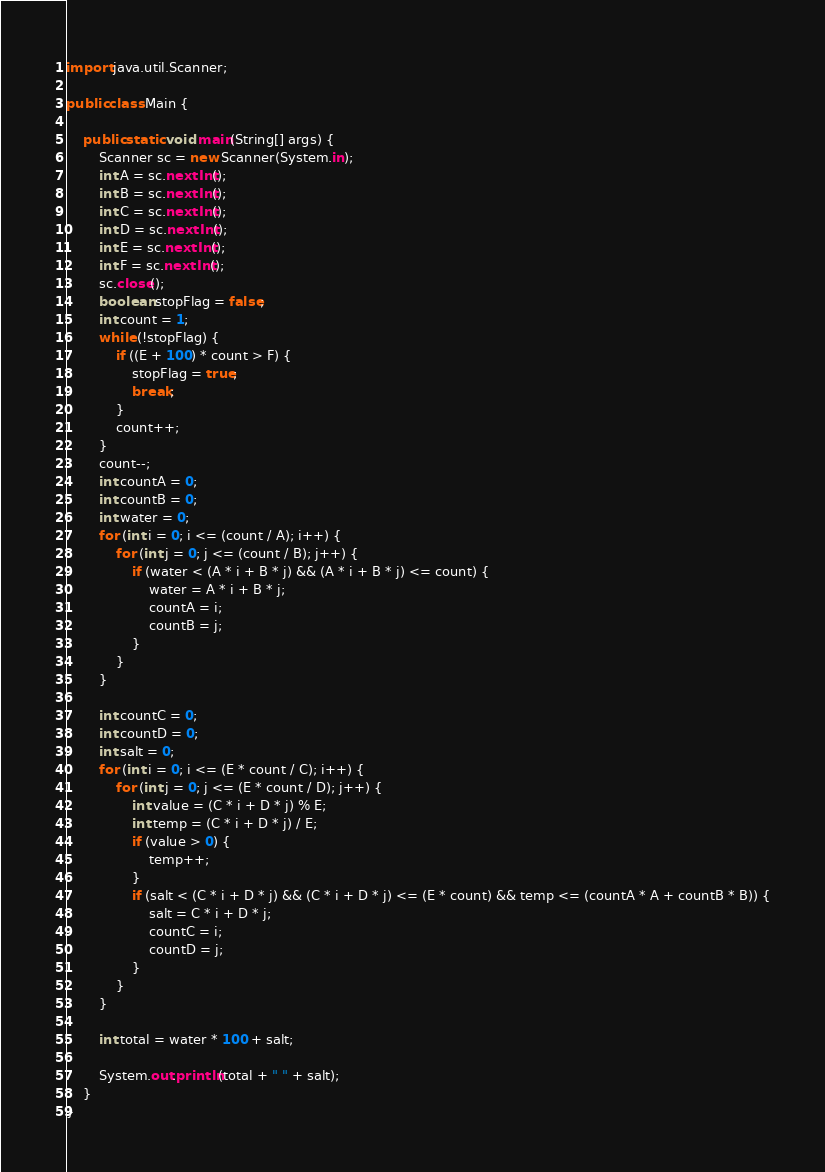Convert code to text. <code><loc_0><loc_0><loc_500><loc_500><_Java_>import java.util.Scanner;

public class Main {

	public static void main(String[] args) {
		Scanner sc = new Scanner(System.in);
		int A = sc.nextInt();
		int B = sc.nextInt();
		int C = sc.nextInt();
		int D = sc.nextInt();
		int E = sc.nextInt();
		int F = sc.nextInt();
		sc.close();
		boolean stopFlag = false;
		int count = 1;
		while (!stopFlag) {
			if ((E + 100) * count > F) {
				stopFlag = true;
				break;
			}
			count++;
		}
		count--;
		int countA = 0;
		int countB = 0;
		int water = 0;
		for (int i = 0; i <= (count / A); i++) {
			for (int j = 0; j <= (count / B); j++) {
				if (water < (A * i + B * j) && (A * i + B * j) <= count) {
					water = A * i + B * j;
					countA = i;
					countB = j;
				}
			}
		}
		
		int countC = 0;
		int countD = 0;
		int salt = 0;
		for (int i = 0; i <= (E * count / C); i++) {
			for (int j = 0; j <= (E * count / D); j++) {
				int value = (C * i + D * j) % E;
				int temp = (C * i + D * j) / E;
				if (value > 0) {
					temp++;
				}
				if (salt < (C * i + D * j) && (C * i + D * j) <= (E * count) && temp <= (countA * A + countB * B)) {
					salt = C * i + D * j;
					countC = i;
					countD = j;
				}
			}
		}
		
		int total = water * 100 + salt;
		
		System.out.println(total + " " + salt);
	}
}</code> 